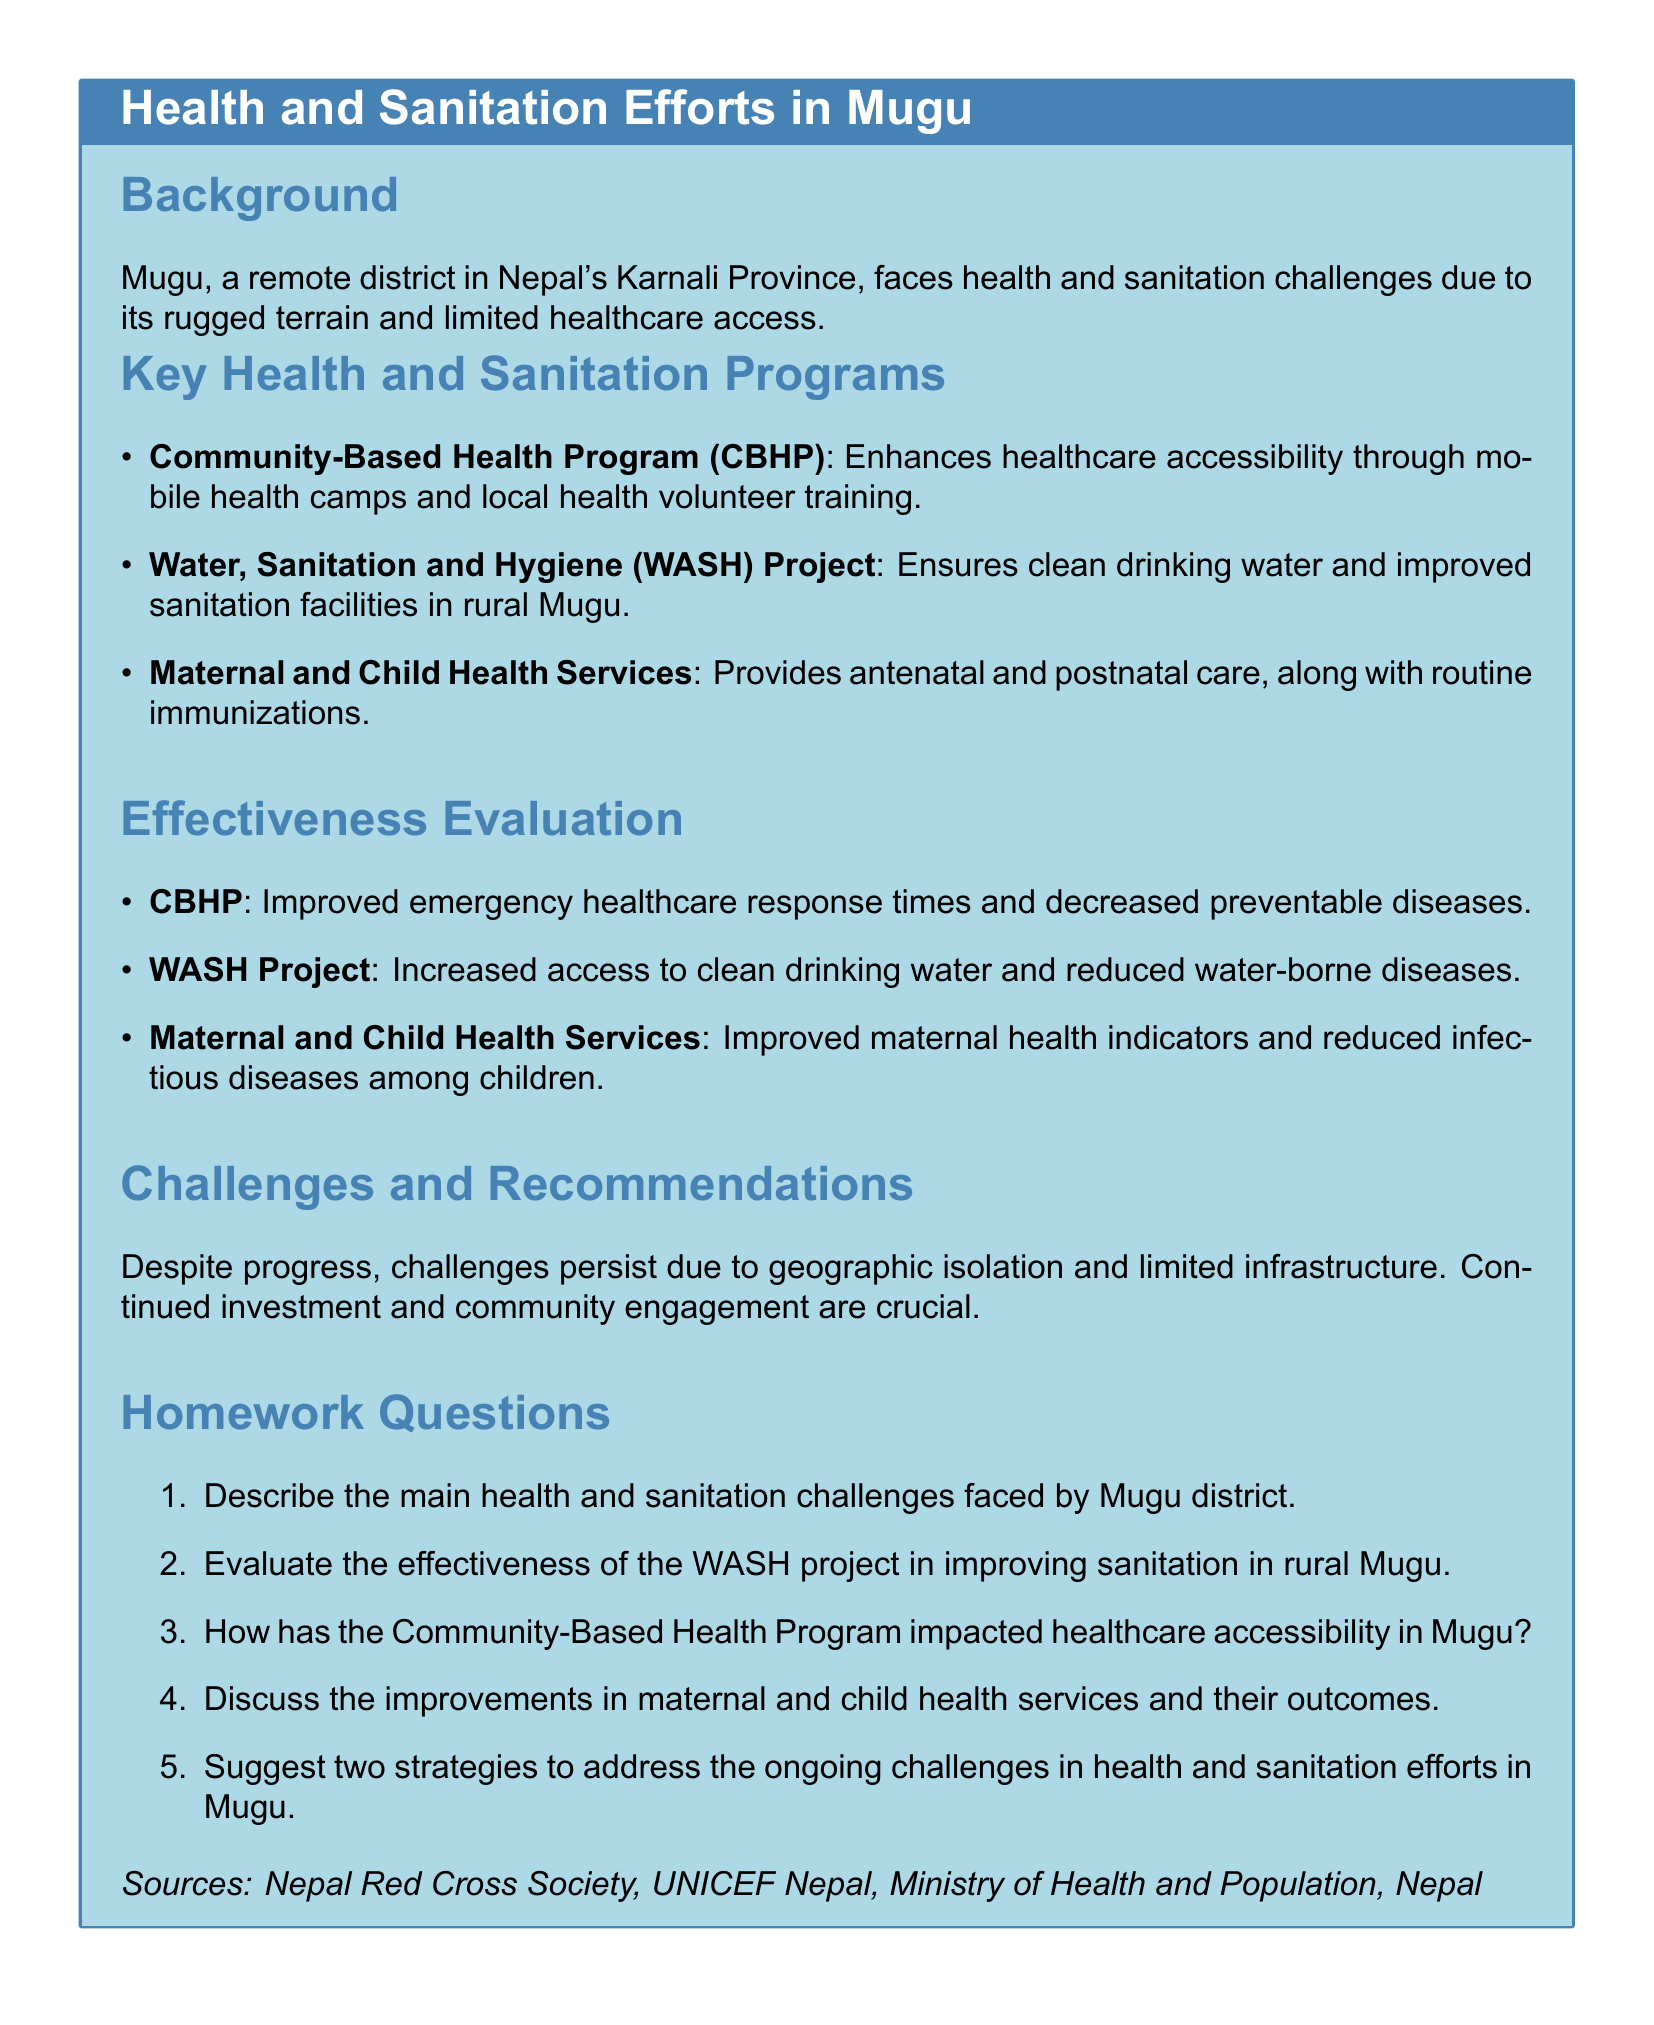What are the health and sanitation challenges in Mugu? The challenges are due to the rugged terrain and limited healthcare access.
Answer: Rugged terrain and limited healthcare access What program enhances healthcare accessibility in Mugu? The program mentioned that enhances healthcare accessibility is the Community-Based Health Program (CBHP).
Answer: Community-Based Health Program (CBHP) Which project ensures clean drinking water in Mugu? The project that ensures clean drinking water is the Water, Sanitation and Hygiene (WASH) Project.
Answer: Water, Sanitation and Hygiene (WASH) Project What is one effect of the WASH Project? One effect of the WASH Project is an increase in access to clean drinking water.
Answer: Increased access to clean drinking water What improvement is noted in maternal health indicators? The document states that maternal health indicators have improved.
Answer: Improved maternal health indicators What type of care is provided by the Maternal and Child Health Services? The type of care provided includes antenatal and postnatal care.
Answer: Antenatal and postnatal care What is a primary challenge mentioned in the document? A primary challenge mentioned is geographic isolation.
Answer: Geographic isolation How many key health and sanitation programs are listed? There are three key health and sanitation programs listed in the document.
Answer: Three 